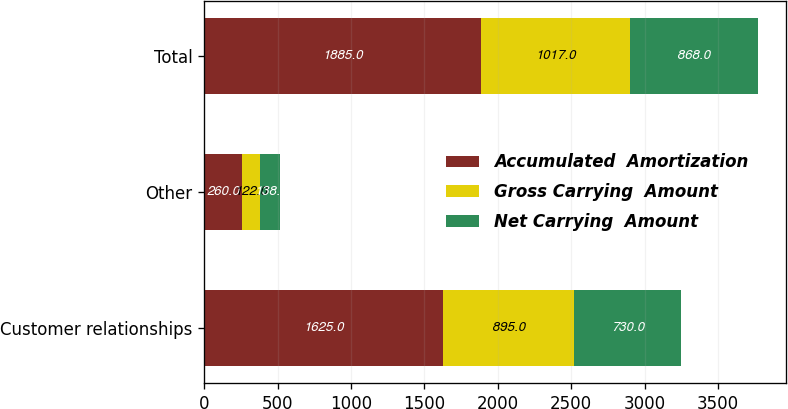Convert chart to OTSL. <chart><loc_0><loc_0><loc_500><loc_500><stacked_bar_chart><ecel><fcel>Customer relationships<fcel>Other<fcel>Total<nl><fcel>Accumulated  Amortization<fcel>1625<fcel>260<fcel>1885<nl><fcel>Gross Carrying  Amount<fcel>895<fcel>122<fcel>1017<nl><fcel>Net Carrying  Amount<fcel>730<fcel>138<fcel>868<nl></chart> 